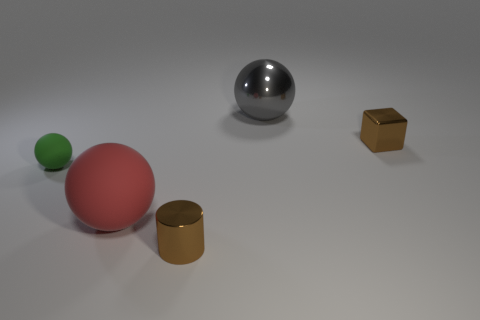Add 3 tiny metallic things. How many objects exist? 8 Subtract all spheres. How many objects are left? 2 Subtract all big green metallic blocks. Subtract all tiny matte spheres. How many objects are left? 4 Add 2 large rubber things. How many large rubber things are left? 3 Add 5 yellow metallic spheres. How many yellow metallic spheres exist? 5 Subtract 0 yellow cylinders. How many objects are left? 5 